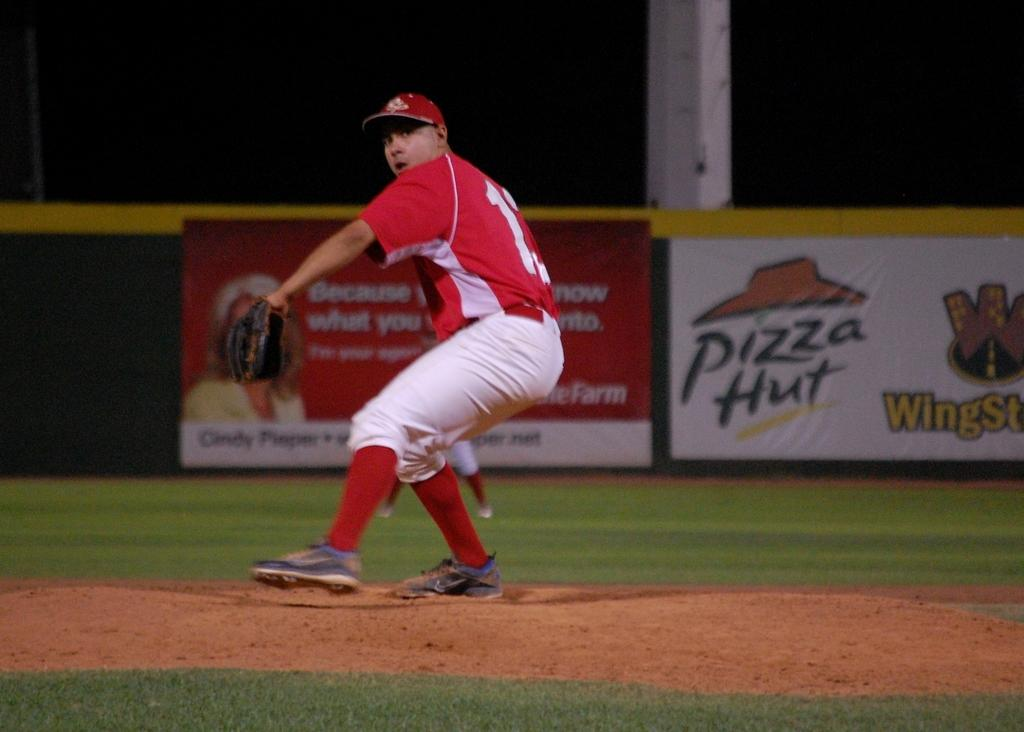<image>
Relay a brief, clear account of the picture shown. A baseball player is playing in front of a pizza Hut banner. 